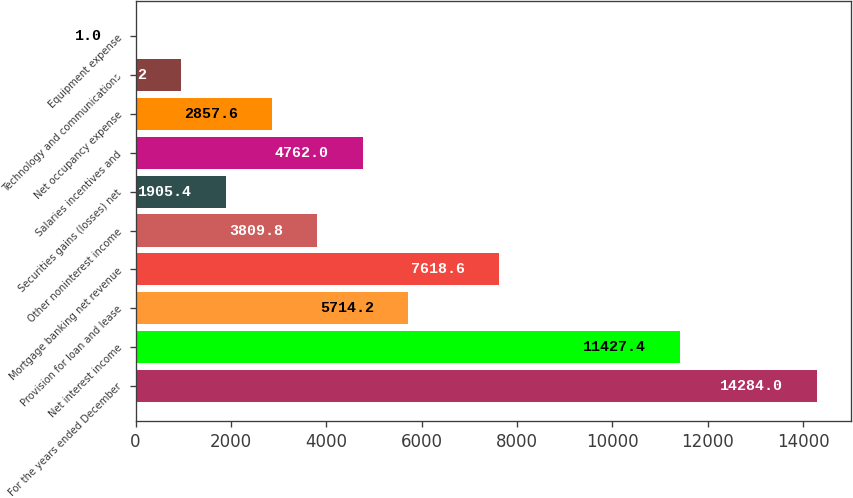Convert chart. <chart><loc_0><loc_0><loc_500><loc_500><bar_chart><fcel>For the years ended December<fcel>Net interest income<fcel>Provision for loan and lease<fcel>Mortgage banking net revenue<fcel>Other noninterest income<fcel>Securities gains (losses) net<fcel>Salaries incentives and<fcel>Net occupancy expense<fcel>Technology and communications<fcel>Equipment expense<nl><fcel>14284<fcel>11427.4<fcel>5714.2<fcel>7618.6<fcel>3809.8<fcel>1905.4<fcel>4762<fcel>2857.6<fcel>953.2<fcel>1<nl></chart> 